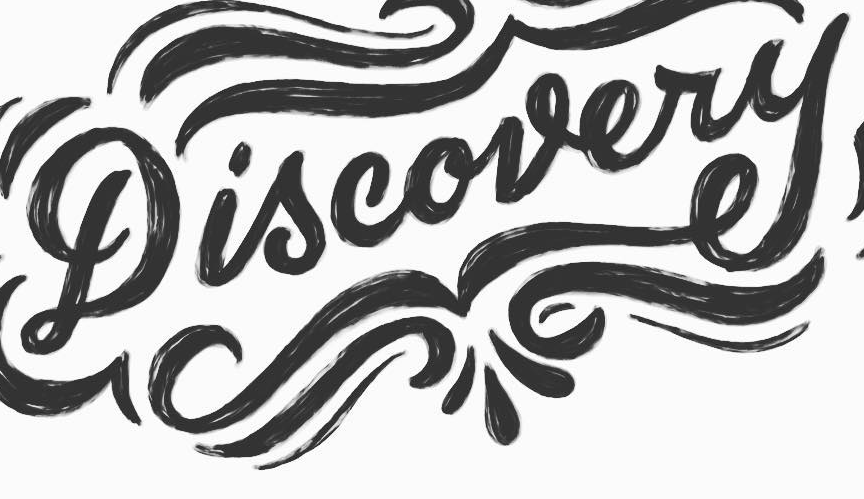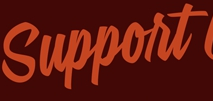Identify the words shown in these images in order, separated by a semicolon. Discovery; Support 